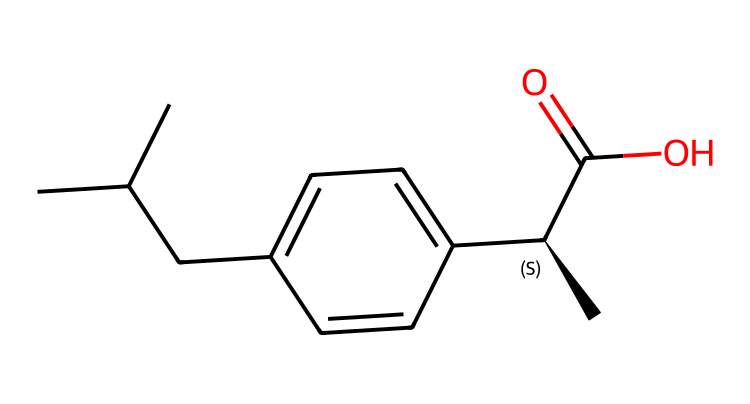What is the IUPAC name of this chemical? The SMILES representation indicates that the structure contains a carboxylic acid group, a chiral center, and is derived from propionic acid. Following IUPAC naming rules, the longest continuous carbon chain around the chiral center is identified. The full name reflects its configuration.
Answer: 2-(4-isobutylphenyl)propanoic acid How many chiral centers are present in this compound? By analyzing the molecular structure and specifically looking for carbon atoms bonded to four different substituents, we can identify chiral centers. In this case, there is one carbon atom that meets this criterion.
Answer: 1 What is the main functional group in this chemical? The SMILES indicates a carbon atom connected to a hydroxyl group (–OH) and a carbonyl group (C=O), which together form a carboxylic acid. This is the primary functional group present, impacting its chemical properties.
Answer: carboxylic acid Does this molecule exhibit optical activity? Since the compound has a chiral center, it can exist in two non-superimposable mirror images, also known as enantiomers. Optical activity arises as these isomers rotate plane-polarized light in different directions.
Answer: yes What kind of isomerism is present in this compound? Given that there is one chiral center in the molecule, the isomers that can arise from it are enantiomers, which are a type of stereoisomer. This specific arrangement leads to different spatial orientations of the atoms.
Answer: stereoisomerism What type of drug is this compound classified as? The structure and the presence of the carboxylic acid functional group suggest its role in inflammation reduction. Thus, it fits into the category of non-steroidal anti-inflammatory drugs (NSAIDs).
Answer: NSAID 